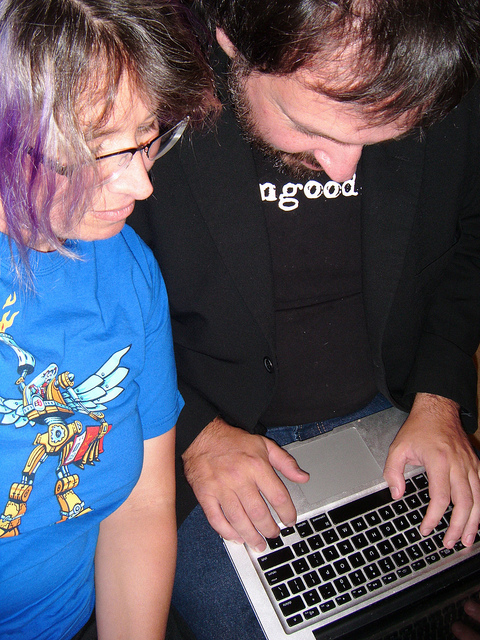<image>What kind of print is on her t-shirt? I don't know what kind of print is on her t-shirt. It can be manga, animation, cartoon, star wars, anime or graphic. What kind of print is on her t-shirt? It is unknown what kind of print is on her t-shirt. It can be seen 'manga', 'animation', 'cartoon', 'star wars', 'anime', 'graphic' or 'silk screen'. 